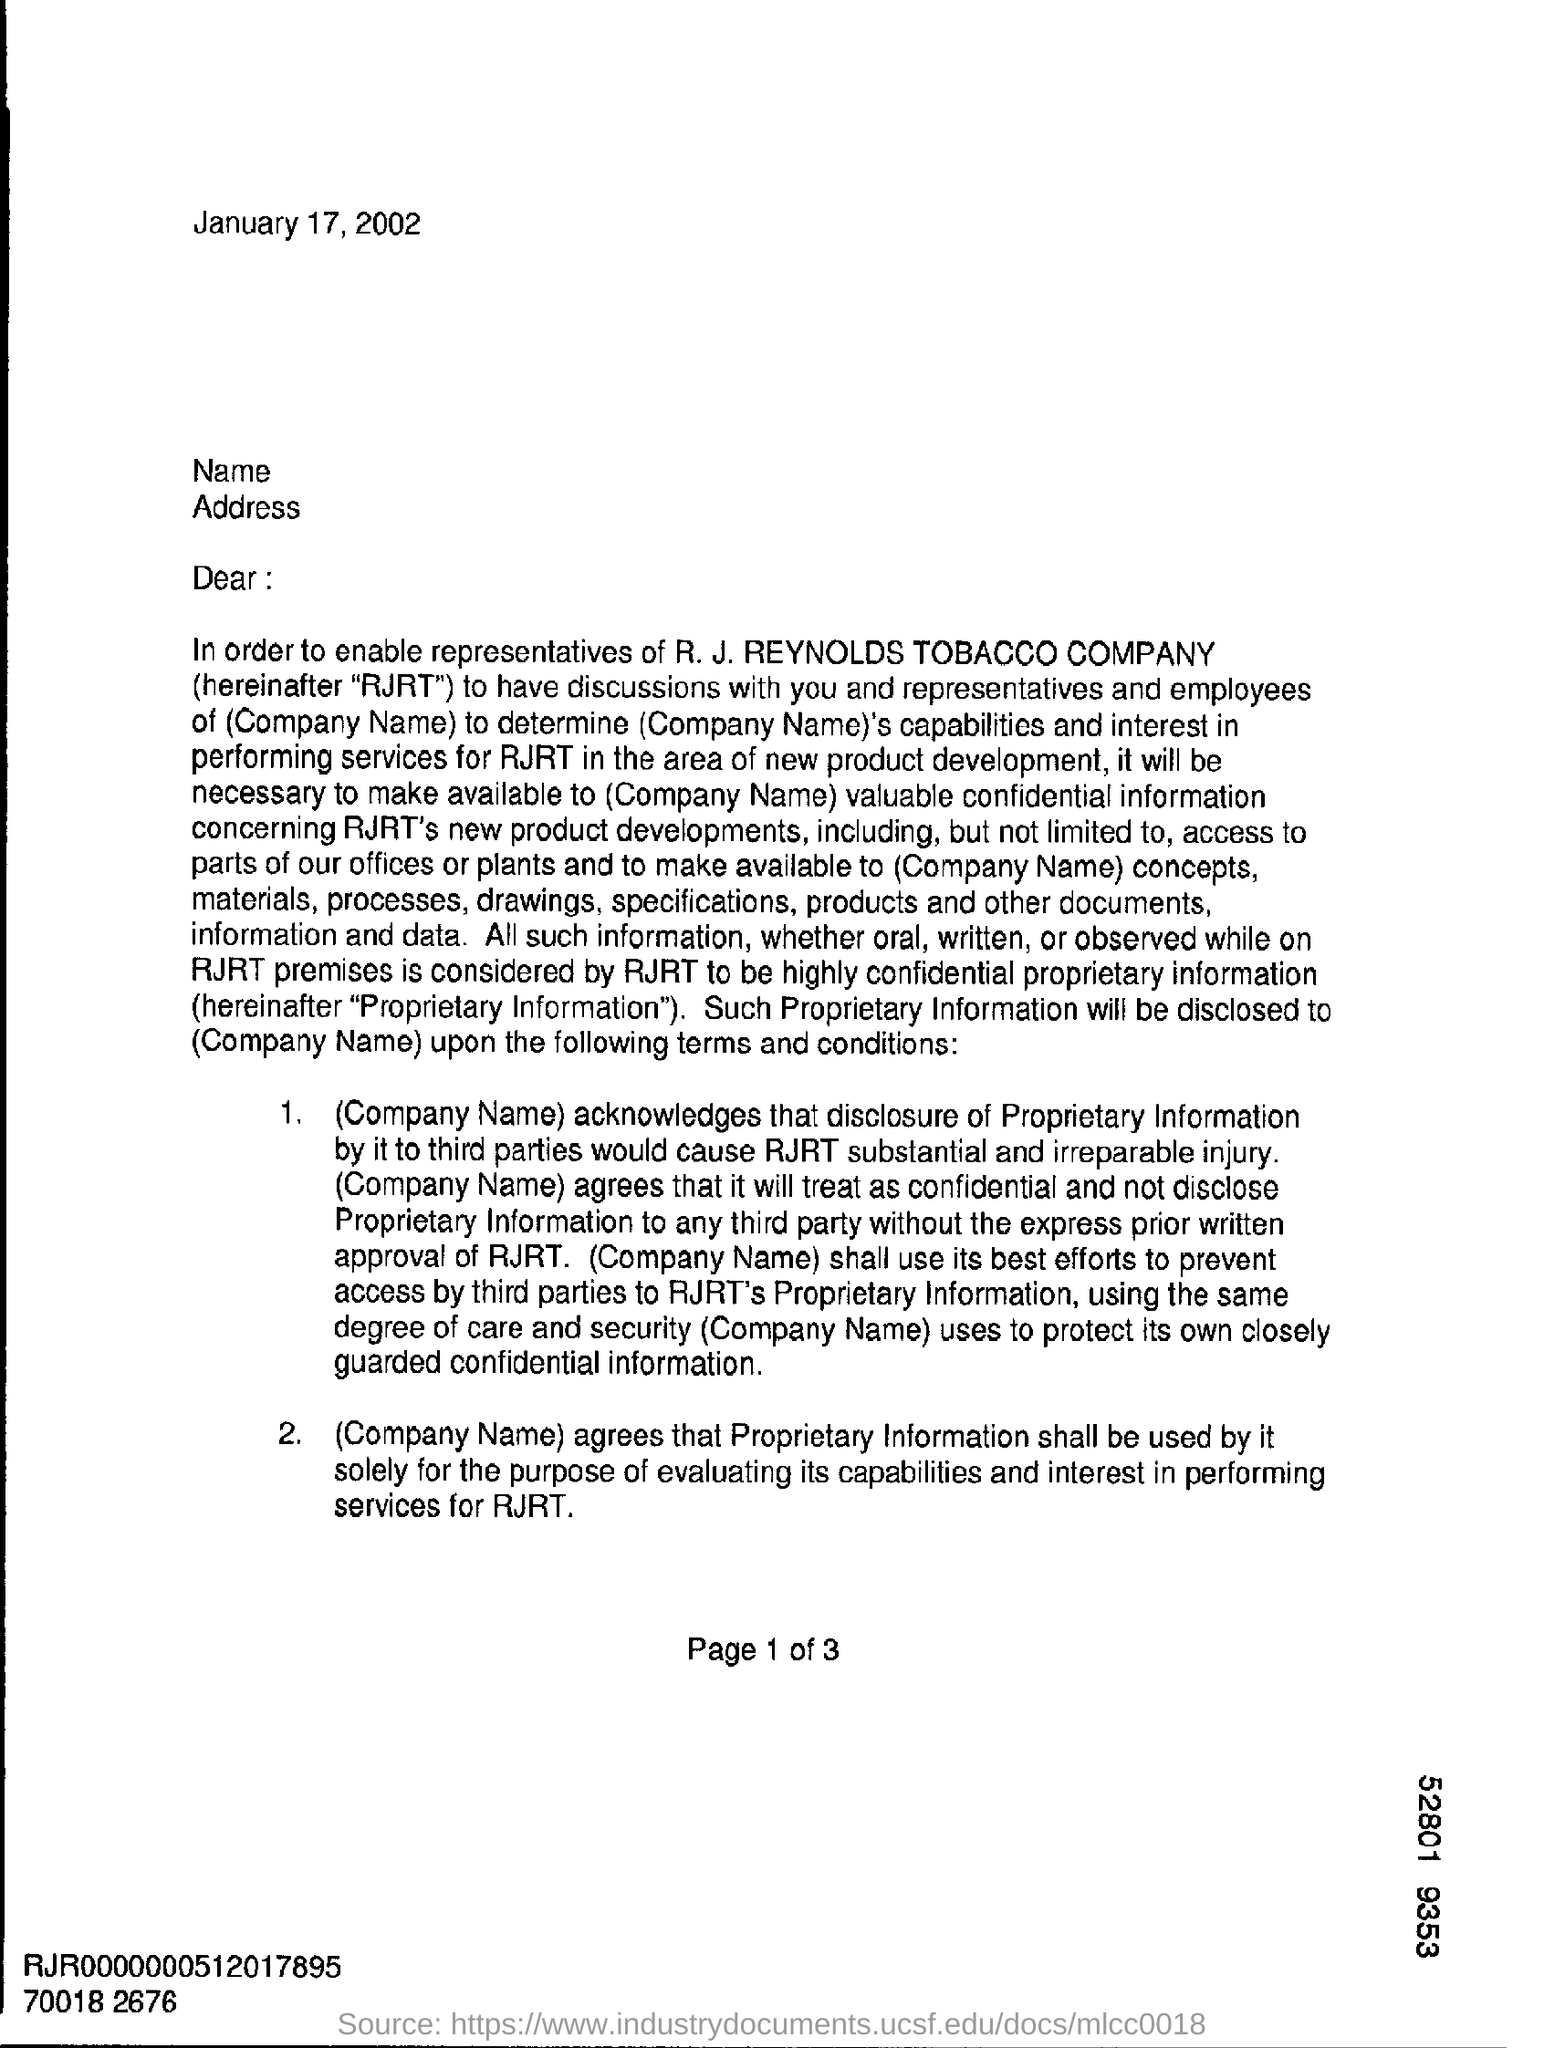What is the date on the document?
Offer a very short reply. January 17, 2002. 